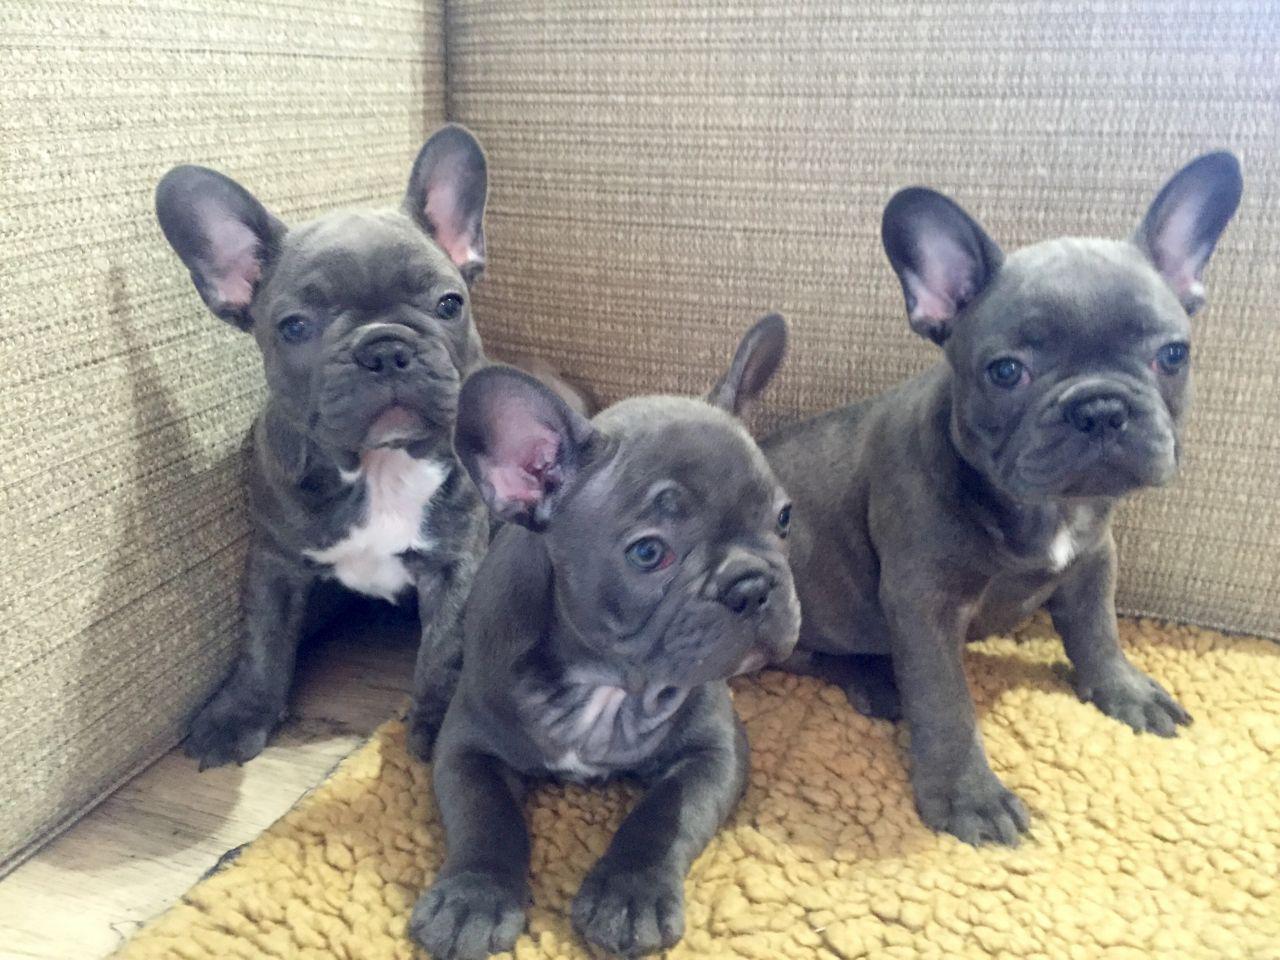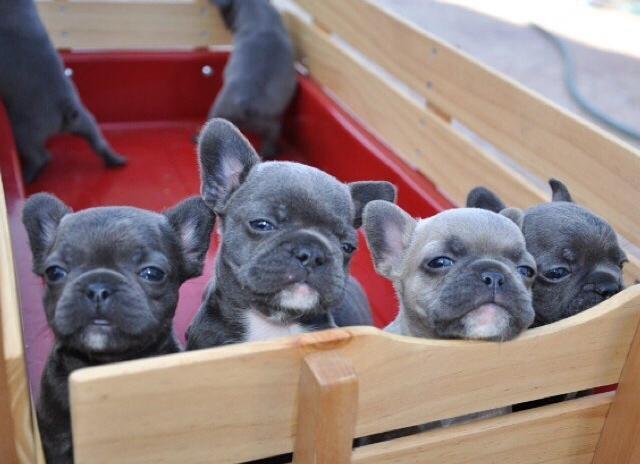The first image is the image on the left, the second image is the image on the right. Examine the images to the left and right. Is the description "There are at least five white and tan puppies along side a single black and white dog." accurate? Answer yes or no. No. 